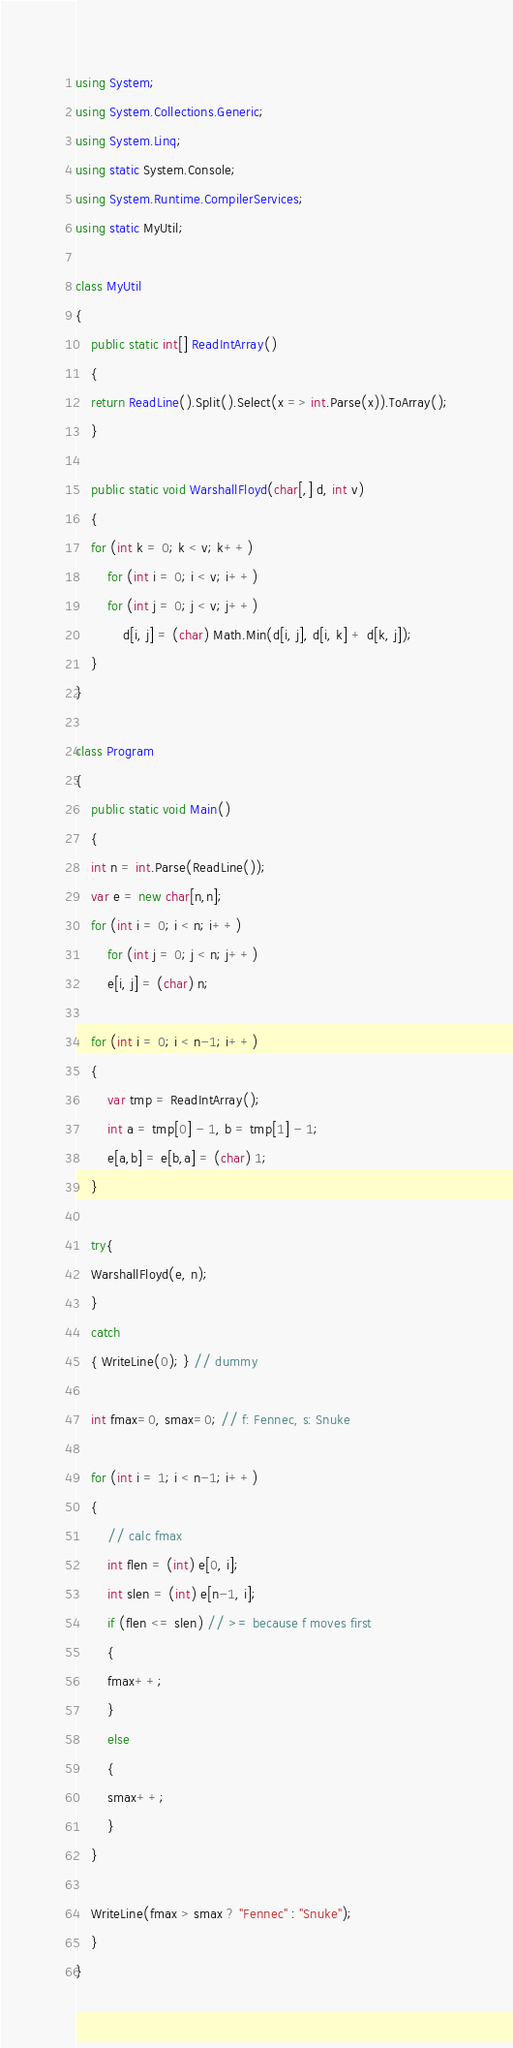Convert code to text. <code><loc_0><loc_0><loc_500><loc_500><_C#_>using System;
using System.Collections.Generic;
using System.Linq;
using static System.Console;
using System.Runtime.CompilerServices;
using static MyUtil;

class MyUtil
{
    public static int[] ReadIntArray()
    {
	return ReadLine().Split().Select(x => int.Parse(x)).ToArray();
    }

    public static void WarshallFloyd(char[,] d, int v)
    {
	for (int k = 0; k < v; k++)
	    for (int i = 0; i < v; i++)
		for (int j = 0; j < v; j++)
		    d[i, j] = (char) Math.Min(d[i, j], d[i, k] + d[k, j]);
    }
}

class Program
{
    public static void Main()
    {
	int n = int.Parse(ReadLine());
	var e = new char[n,n];
	for (int i = 0; i < n; i++)
	    for (int j = 0; j < n; j++)
		e[i, j] = (char) n;

	for (int i = 0; i < n-1; i++)
	{
	    var tmp = ReadIntArray();
	    int a = tmp[0] - 1, b = tmp[1] - 1;
	    e[a,b] = e[b,a] = (char) 1;
	}

	try{
	WarshallFloyd(e, n);
	}
	catch
	{ WriteLine(0); } // dummy

	int fmax=0, smax=0; // f: Fennec, s: Snuke

	for (int i = 1; i < n-1; i++)
	{
	    // calc fmax
	    int flen = (int) e[0, i];
	    int slen = (int) e[n-1, i];
	    if (flen <= slen) // >= because f moves first
	    {
		fmax++;
	    }
	    else
	    {
		smax++;
	    }
	}

	WriteLine(fmax > smax ? "Fennec" : "Snuke");
    }
}
</code> 